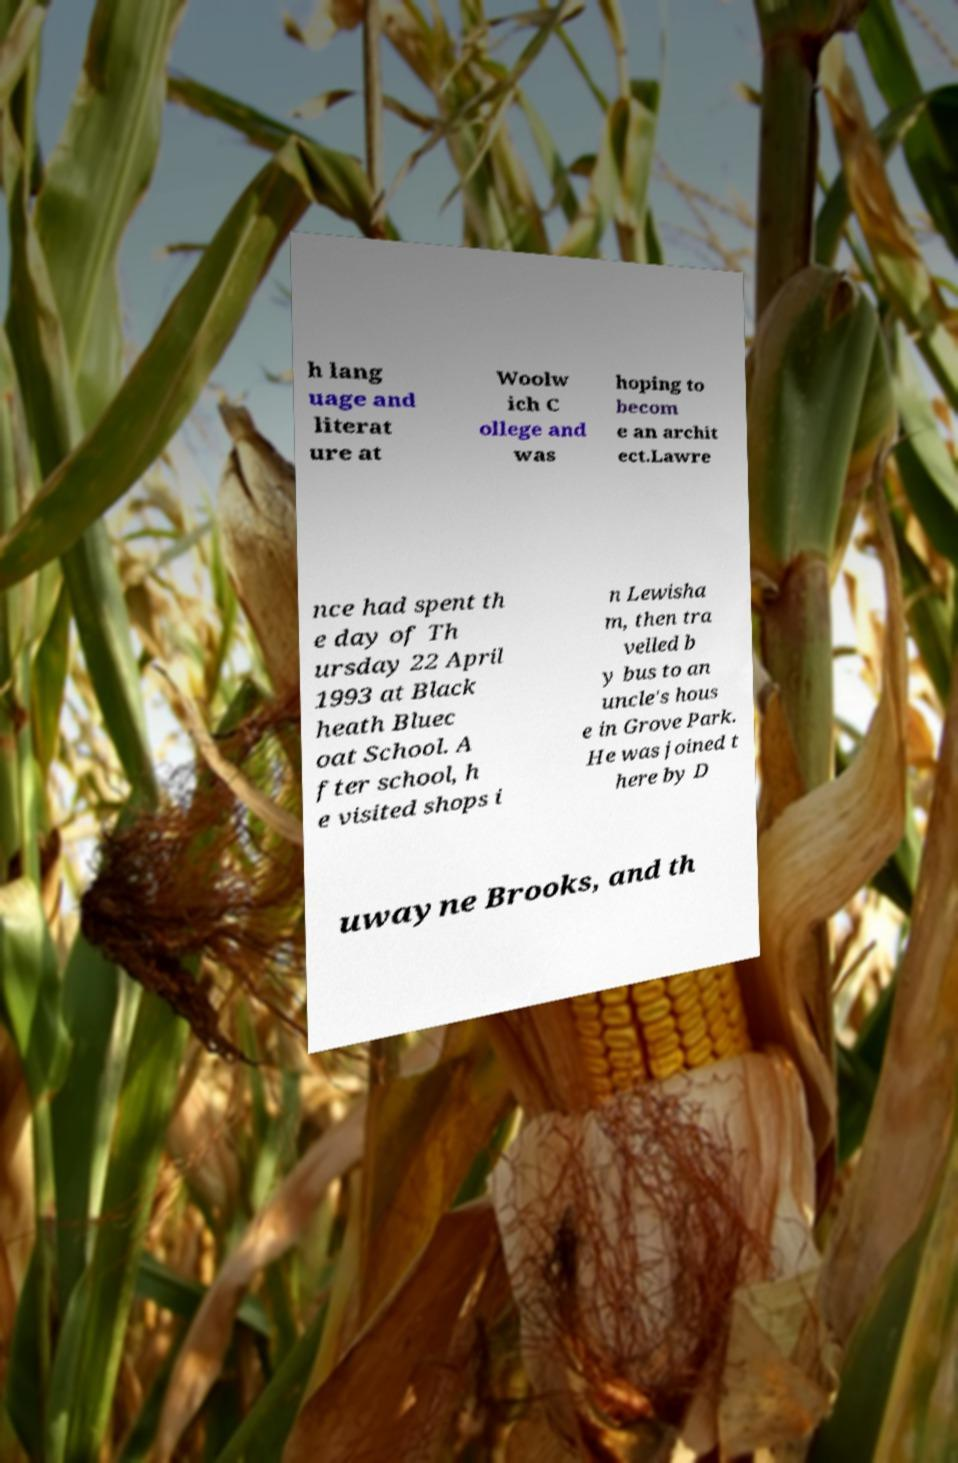Can you accurately transcribe the text from the provided image for me? h lang uage and literat ure at Woolw ich C ollege and was hoping to becom e an archit ect.Lawre nce had spent th e day of Th ursday 22 April 1993 at Black heath Bluec oat School. A fter school, h e visited shops i n Lewisha m, then tra velled b y bus to an uncle's hous e in Grove Park. He was joined t here by D uwayne Brooks, and th 